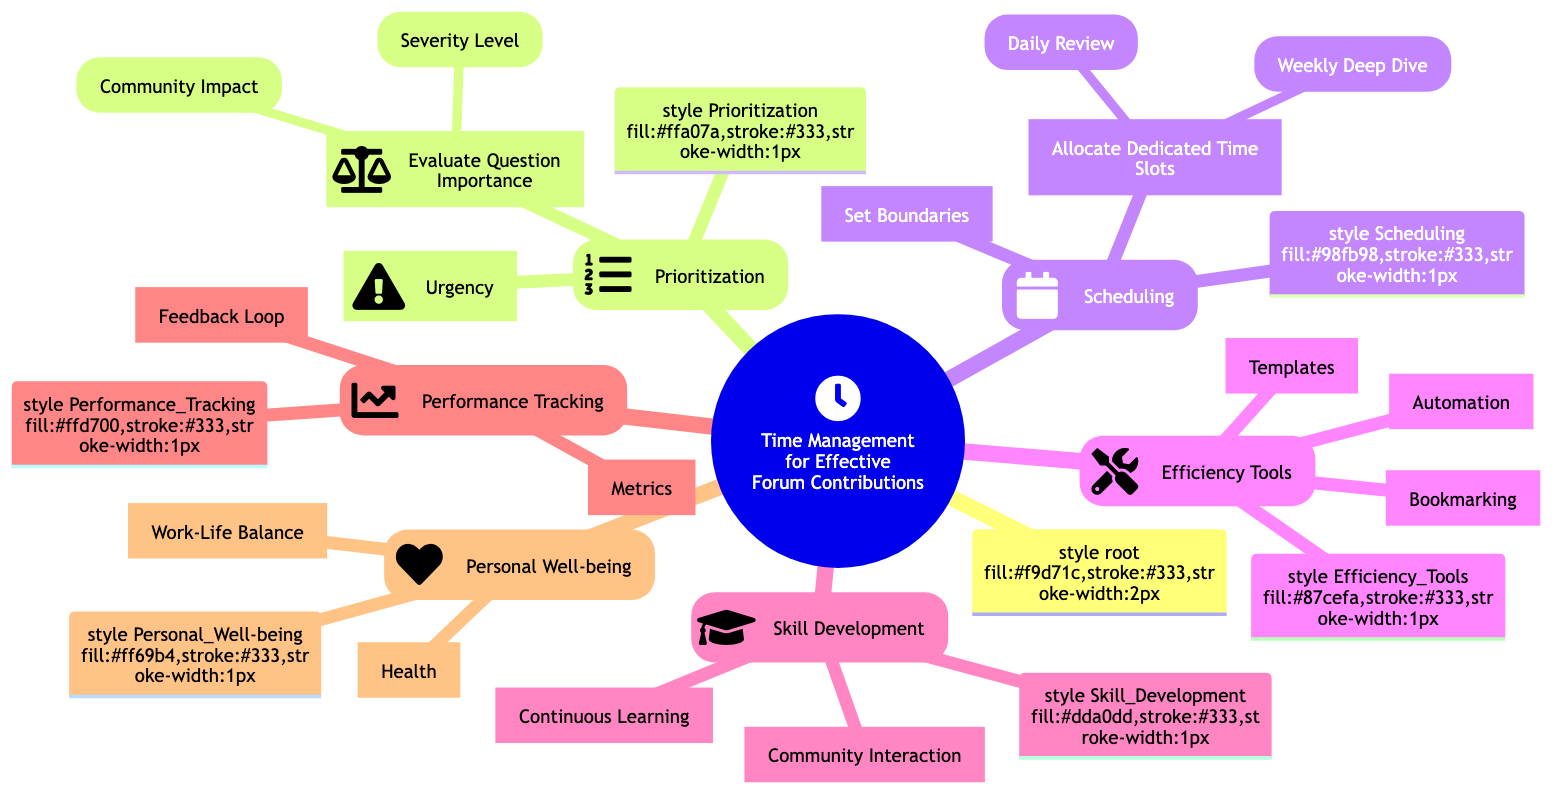What are the two main categories under Prioritization? The diagram illustrates that under the Prioritization node, there are two main categories: Evaluate Question Importance and Urgency.
Answer: Evaluate Question Importance, Urgency How many levels are included under Severity Level? The Severity Level node includes three levels: Critical Bug, Moderate Issue, and Minor Query, making a total of three levels.
Answer: Three levels What does 'Daily Review' fall under in the diagram? The Daily Review is shown as a subset of Allocate Dedicated Time Slots, which is part of the Scheduling category.
Answer: Allocate Dedicated Time Slots Which two elements ensure Personal Well-being? Under the Personal Well-being category, the elements ensuring well-being are Work-Life Balance and Health.
Answer: Work-Life Balance, Health What is one key aspect of Efficiency Tools? The diagram indicates Automation as one of the key aspects categorized under Efficiency Tools.
Answer: Automation How does Performance Tracking help contributors? The diagram shows that Performance Tracking includes metrics such as Response Time and Answer Quality, along with a Feedback Loop, enhancing the effectiveness of contributors.
Answer: Metrics, Feedback Loop Which two activities fall under Skill Development? The Skill Development node has two activities: Continuous Learning and Community Interaction, focusing on enhancing the contributor's skills.
Answer: Continuous Learning, Community Interaction What is the impact of setting boundaries in Scheduling? The diagram illustrates that setting boundaries in Scheduling includes Limiting Session Duration and Avoiding Burnout, which are essential to managing time effectively.
Answer: Limiting Session Duration, Avoiding Burnout What type of tools does the Efficiency Tools category include? The Efficiency Tools include three types: Automation, Templates, and Bookmarking, which help streamline tasks for forum contributions.
Answer: Automation, Templates, Bookmarking 